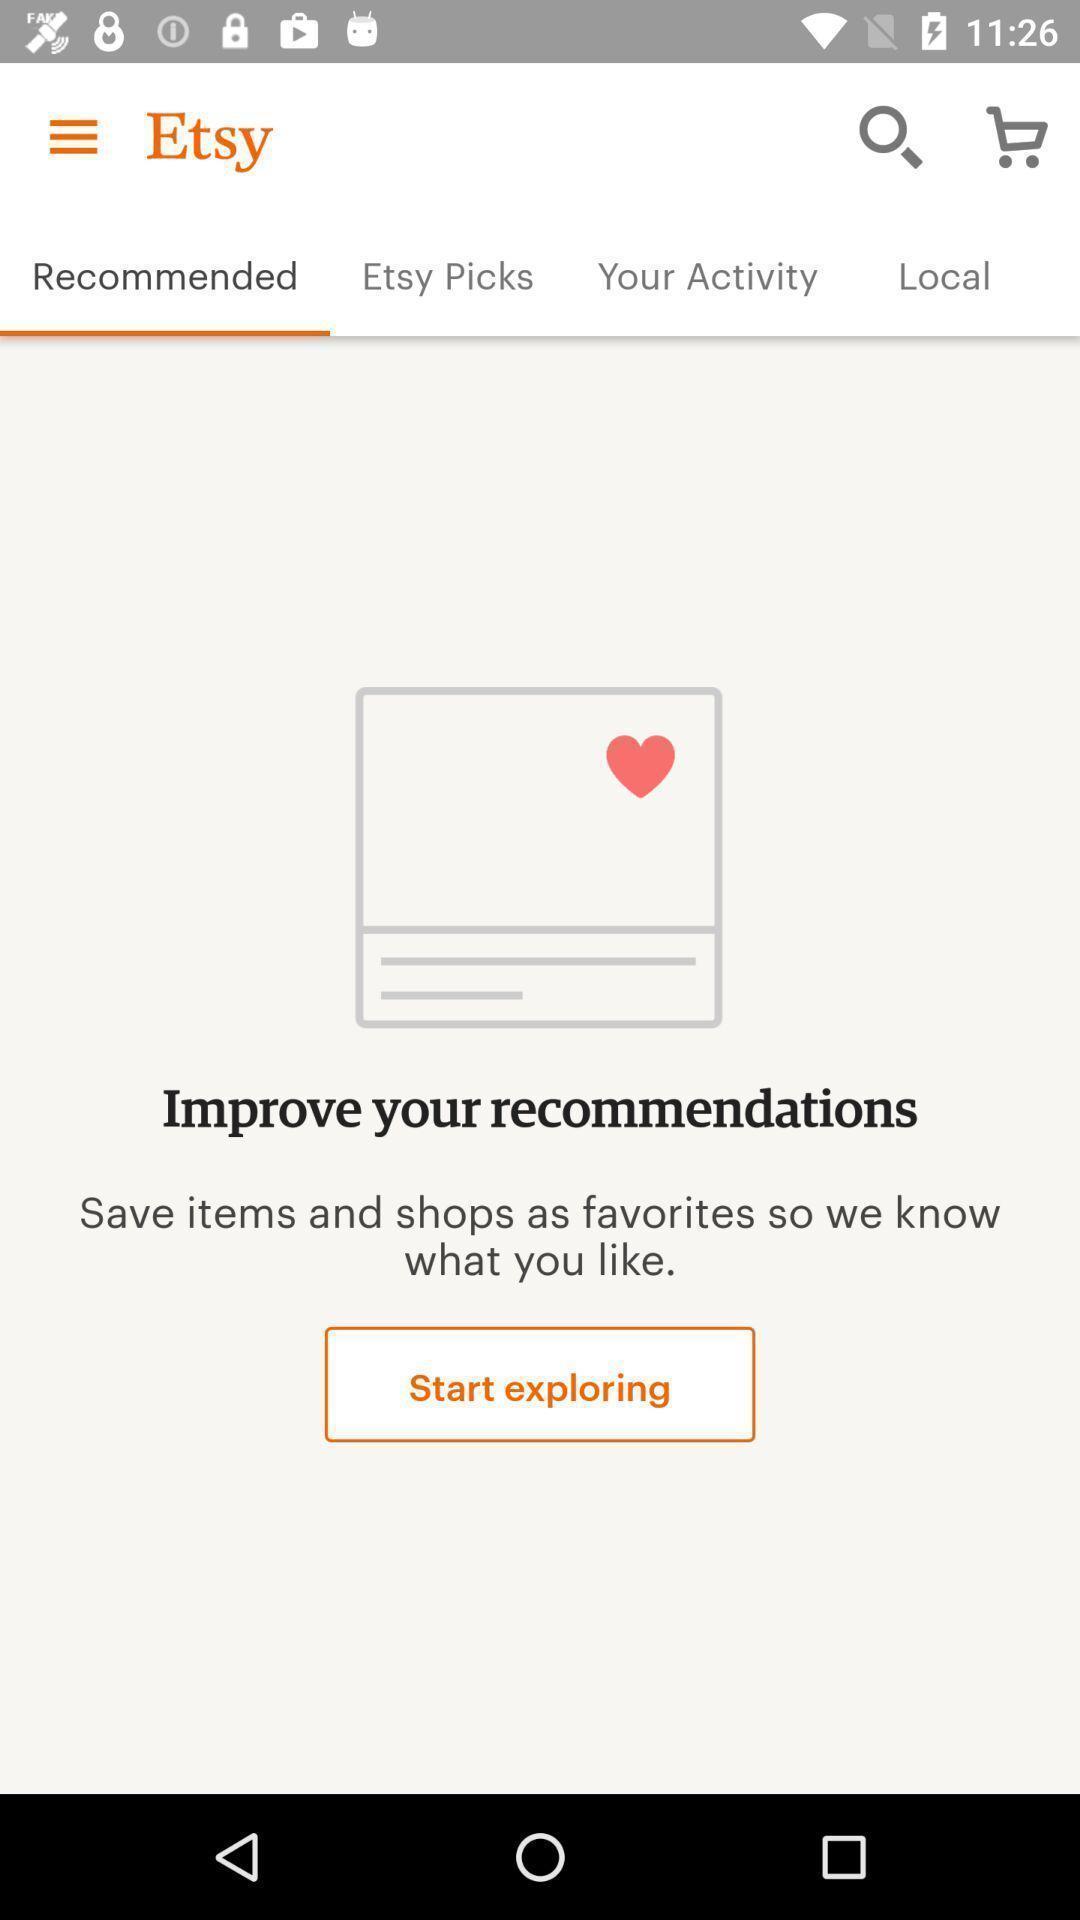What is the overall content of this screenshot? Results for recommended page in an shopping app. 